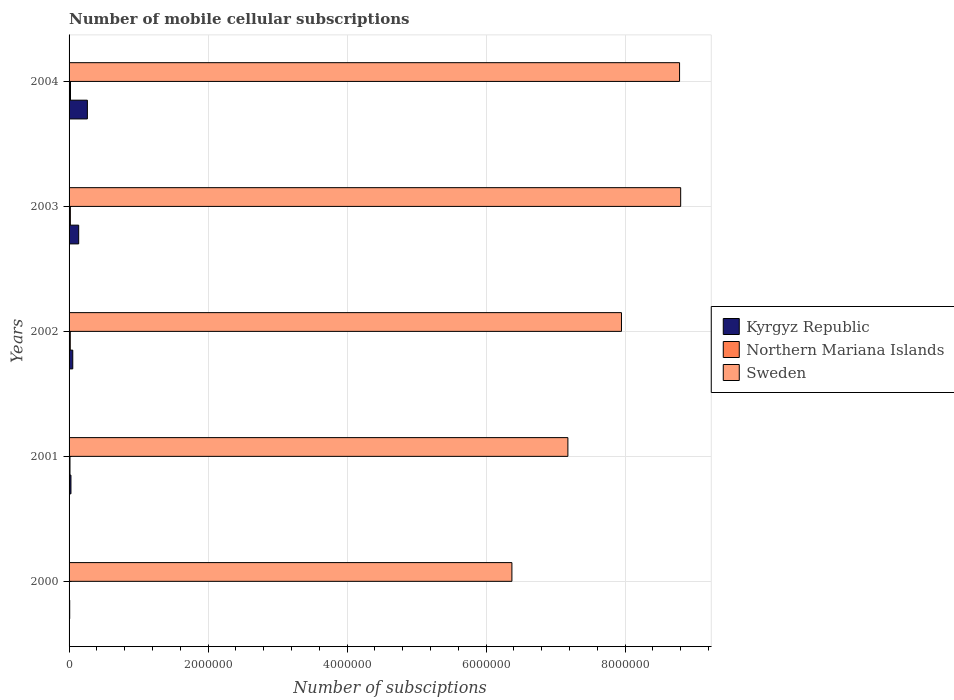How many groups of bars are there?
Your answer should be very brief. 5. Are the number of bars per tick equal to the number of legend labels?
Offer a very short reply. Yes. What is the label of the 4th group of bars from the top?
Your answer should be very brief. 2001. What is the number of mobile cellular subscriptions in Sweden in 2002?
Your answer should be very brief. 7.95e+06. Across all years, what is the maximum number of mobile cellular subscriptions in Sweden?
Make the answer very short. 8.80e+06. Across all years, what is the minimum number of mobile cellular subscriptions in Northern Mariana Islands?
Give a very brief answer. 3000. In which year was the number of mobile cellular subscriptions in Kyrgyz Republic maximum?
Provide a short and direct response. 2004. What is the total number of mobile cellular subscriptions in Kyrgyz Republic in the graph?
Ensure brevity in your answer.  4.91e+05. What is the difference between the number of mobile cellular subscriptions in Sweden in 2000 and that in 2001?
Provide a short and direct response. -8.06e+05. What is the difference between the number of mobile cellular subscriptions in Sweden in 2004 and the number of mobile cellular subscriptions in Northern Mariana Islands in 2002?
Provide a short and direct response. 8.77e+06. What is the average number of mobile cellular subscriptions in Sweden per year?
Make the answer very short. 7.82e+06. In the year 2002, what is the difference between the number of mobile cellular subscriptions in Northern Mariana Islands and number of mobile cellular subscriptions in Sweden?
Ensure brevity in your answer.  -7.93e+06. What is the ratio of the number of mobile cellular subscriptions in Kyrgyz Republic in 2002 to that in 2003?
Provide a succinct answer. 0.38. Is the number of mobile cellular subscriptions in Northern Mariana Islands in 2001 less than that in 2004?
Ensure brevity in your answer.  Yes. What is the difference between the highest and the second highest number of mobile cellular subscriptions in Sweden?
Your answer should be compact. 1.60e+04. What is the difference between the highest and the lowest number of mobile cellular subscriptions in Sweden?
Your answer should be very brief. 2.43e+06. In how many years, is the number of mobile cellular subscriptions in Sweden greater than the average number of mobile cellular subscriptions in Sweden taken over all years?
Your response must be concise. 3. What does the 1st bar from the top in 2001 represents?
Make the answer very short. Sweden. What does the 3rd bar from the bottom in 2003 represents?
Provide a short and direct response. Sweden. How many bars are there?
Ensure brevity in your answer.  15. Are all the bars in the graph horizontal?
Provide a short and direct response. Yes. How many years are there in the graph?
Give a very brief answer. 5. What is the difference between two consecutive major ticks on the X-axis?
Provide a short and direct response. 2.00e+06. Does the graph contain any zero values?
Provide a short and direct response. No. Does the graph contain grids?
Offer a very short reply. Yes. Where does the legend appear in the graph?
Keep it short and to the point. Center right. How are the legend labels stacked?
Your answer should be compact. Vertical. What is the title of the graph?
Your answer should be compact. Number of mobile cellular subscriptions. What is the label or title of the X-axis?
Keep it short and to the point. Number of subsciptions. What is the label or title of the Y-axis?
Ensure brevity in your answer.  Years. What is the Number of subsciptions of Kyrgyz Republic in 2000?
Ensure brevity in your answer.  9000. What is the Number of subsciptions in Northern Mariana Islands in 2000?
Keep it short and to the point. 3000. What is the Number of subsciptions of Sweden in 2000?
Offer a very short reply. 6.37e+06. What is the Number of subsciptions in Kyrgyz Republic in 2001?
Make the answer very short. 2.70e+04. What is the Number of subsciptions of Northern Mariana Islands in 2001?
Make the answer very short. 1.32e+04. What is the Number of subsciptions in Sweden in 2001?
Offer a very short reply. 7.18e+06. What is the Number of subsciptions of Kyrgyz Republic in 2002?
Offer a very short reply. 5.31e+04. What is the Number of subsciptions of Northern Mariana Islands in 2002?
Give a very brief answer. 1.71e+04. What is the Number of subsciptions of Sweden in 2002?
Your answer should be very brief. 7.95e+06. What is the Number of subsciptions of Kyrgyz Republic in 2003?
Your answer should be very brief. 1.38e+05. What is the Number of subsciptions in Northern Mariana Islands in 2003?
Ensure brevity in your answer.  1.86e+04. What is the Number of subsciptions of Sweden in 2003?
Your answer should be compact. 8.80e+06. What is the Number of subsciptions of Kyrgyz Republic in 2004?
Give a very brief answer. 2.63e+05. What is the Number of subsciptions in Northern Mariana Islands in 2004?
Keep it short and to the point. 2.05e+04. What is the Number of subsciptions in Sweden in 2004?
Ensure brevity in your answer.  8.78e+06. Across all years, what is the maximum Number of subsciptions in Kyrgyz Republic?
Provide a succinct answer. 2.63e+05. Across all years, what is the maximum Number of subsciptions of Northern Mariana Islands?
Your response must be concise. 2.05e+04. Across all years, what is the maximum Number of subsciptions of Sweden?
Provide a succinct answer. 8.80e+06. Across all years, what is the minimum Number of subsciptions of Kyrgyz Republic?
Offer a very short reply. 9000. Across all years, what is the minimum Number of subsciptions of Northern Mariana Islands?
Offer a very short reply. 3000. Across all years, what is the minimum Number of subsciptions in Sweden?
Your answer should be compact. 6.37e+06. What is the total Number of subsciptions in Kyrgyz Republic in the graph?
Provide a short and direct response. 4.91e+05. What is the total Number of subsciptions of Northern Mariana Islands in the graph?
Your answer should be very brief. 7.24e+04. What is the total Number of subsciptions of Sweden in the graph?
Your answer should be compact. 3.91e+07. What is the difference between the Number of subsciptions in Kyrgyz Republic in 2000 and that in 2001?
Your answer should be compact. -1.80e+04. What is the difference between the Number of subsciptions in Northern Mariana Islands in 2000 and that in 2001?
Provide a succinct answer. -1.02e+04. What is the difference between the Number of subsciptions of Sweden in 2000 and that in 2001?
Your response must be concise. -8.06e+05. What is the difference between the Number of subsciptions of Kyrgyz Republic in 2000 and that in 2002?
Offer a very short reply. -4.41e+04. What is the difference between the Number of subsciptions of Northern Mariana Islands in 2000 and that in 2002?
Offer a terse response. -1.41e+04. What is the difference between the Number of subsciptions in Sweden in 2000 and that in 2002?
Your response must be concise. -1.58e+06. What is the difference between the Number of subsciptions in Kyrgyz Republic in 2000 and that in 2003?
Make the answer very short. -1.29e+05. What is the difference between the Number of subsciptions of Northern Mariana Islands in 2000 and that in 2003?
Offer a terse response. -1.56e+04. What is the difference between the Number of subsciptions in Sweden in 2000 and that in 2003?
Your response must be concise. -2.43e+06. What is the difference between the Number of subsciptions of Kyrgyz Republic in 2000 and that in 2004?
Keep it short and to the point. -2.54e+05. What is the difference between the Number of subsciptions of Northern Mariana Islands in 2000 and that in 2004?
Keep it short and to the point. -1.75e+04. What is the difference between the Number of subsciptions of Sweden in 2000 and that in 2004?
Ensure brevity in your answer.  -2.41e+06. What is the difference between the Number of subsciptions in Kyrgyz Republic in 2001 and that in 2002?
Ensure brevity in your answer.  -2.61e+04. What is the difference between the Number of subsciptions in Northern Mariana Islands in 2001 and that in 2002?
Your response must be concise. -3937. What is the difference between the Number of subsciptions of Sweden in 2001 and that in 2002?
Keep it short and to the point. -7.71e+05. What is the difference between the Number of subsciptions in Kyrgyz Republic in 2001 and that in 2003?
Provide a short and direct response. -1.11e+05. What is the difference between the Number of subsciptions of Northern Mariana Islands in 2001 and that in 2003?
Offer a very short reply. -5419. What is the difference between the Number of subsciptions of Sweden in 2001 and that in 2003?
Give a very brief answer. -1.62e+06. What is the difference between the Number of subsciptions in Kyrgyz Republic in 2001 and that in 2004?
Give a very brief answer. -2.36e+05. What is the difference between the Number of subsciptions of Northern Mariana Islands in 2001 and that in 2004?
Your answer should be very brief. -7274. What is the difference between the Number of subsciptions of Sweden in 2001 and that in 2004?
Provide a short and direct response. -1.61e+06. What is the difference between the Number of subsciptions of Kyrgyz Republic in 2002 and that in 2003?
Give a very brief answer. -8.52e+04. What is the difference between the Number of subsciptions in Northern Mariana Islands in 2002 and that in 2003?
Your answer should be very brief. -1482. What is the difference between the Number of subsciptions of Sweden in 2002 and that in 2003?
Your response must be concise. -8.52e+05. What is the difference between the Number of subsciptions of Kyrgyz Republic in 2002 and that in 2004?
Offer a terse response. -2.10e+05. What is the difference between the Number of subsciptions in Northern Mariana Islands in 2002 and that in 2004?
Keep it short and to the point. -3337. What is the difference between the Number of subsciptions in Sweden in 2002 and that in 2004?
Provide a short and direct response. -8.36e+05. What is the difference between the Number of subsciptions in Kyrgyz Republic in 2003 and that in 2004?
Keep it short and to the point. -1.25e+05. What is the difference between the Number of subsciptions of Northern Mariana Islands in 2003 and that in 2004?
Your answer should be compact. -1855. What is the difference between the Number of subsciptions in Sweden in 2003 and that in 2004?
Your answer should be very brief. 1.60e+04. What is the difference between the Number of subsciptions of Kyrgyz Republic in 2000 and the Number of subsciptions of Northern Mariana Islands in 2001?
Keep it short and to the point. -4200. What is the difference between the Number of subsciptions of Kyrgyz Republic in 2000 and the Number of subsciptions of Sweden in 2001?
Ensure brevity in your answer.  -7.17e+06. What is the difference between the Number of subsciptions in Northern Mariana Islands in 2000 and the Number of subsciptions in Sweden in 2001?
Provide a succinct answer. -7.18e+06. What is the difference between the Number of subsciptions in Kyrgyz Republic in 2000 and the Number of subsciptions in Northern Mariana Islands in 2002?
Provide a succinct answer. -8137. What is the difference between the Number of subsciptions in Kyrgyz Republic in 2000 and the Number of subsciptions in Sweden in 2002?
Your answer should be compact. -7.94e+06. What is the difference between the Number of subsciptions in Northern Mariana Islands in 2000 and the Number of subsciptions in Sweden in 2002?
Provide a succinct answer. -7.95e+06. What is the difference between the Number of subsciptions in Kyrgyz Republic in 2000 and the Number of subsciptions in Northern Mariana Islands in 2003?
Provide a short and direct response. -9619. What is the difference between the Number of subsciptions in Kyrgyz Republic in 2000 and the Number of subsciptions in Sweden in 2003?
Provide a short and direct response. -8.79e+06. What is the difference between the Number of subsciptions in Northern Mariana Islands in 2000 and the Number of subsciptions in Sweden in 2003?
Give a very brief answer. -8.80e+06. What is the difference between the Number of subsciptions in Kyrgyz Republic in 2000 and the Number of subsciptions in Northern Mariana Islands in 2004?
Provide a short and direct response. -1.15e+04. What is the difference between the Number of subsciptions of Kyrgyz Republic in 2000 and the Number of subsciptions of Sweden in 2004?
Offer a very short reply. -8.78e+06. What is the difference between the Number of subsciptions in Northern Mariana Islands in 2000 and the Number of subsciptions in Sweden in 2004?
Give a very brief answer. -8.78e+06. What is the difference between the Number of subsciptions in Kyrgyz Republic in 2001 and the Number of subsciptions in Northern Mariana Islands in 2002?
Offer a terse response. 9863. What is the difference between the Number of subsciptions in Kyrgyz Republic in 2001 and the Number of subsciptions in Sweden in 2002?
Your answer should be compact. -7.92e+06. What is the difference between the Number of subsciptions in Northern Mariana Islands in 2001 and the Number of subsciptions in Sweden in 2002?
Ensure brevity in your answer.  -7.94e+06. What is the difference between the Number of subsciptions of Kyrgyz Republic in 2001 and the Number of subsciptions of Northern Mariana Islands in 2003?
Your response must be concise. 8381. What is the difference between the Number of subsciptions of Kyrgyz Republic in 2001 and the Number of subsciptions of Sweden in 2003?
Keep it short and to the point. -8.77e+06. What is the difference between the Number of subsciptions in Northern Mariana Islands in 2001 and the Number of subsciptions in Sweden in 2003?
Your answer should be compact. -8.79e+06. What is the difference between the Number of subsciptions of Kyrgyz Republic in 2001 and the Number of subsciptions of Northern Mariana Islands in 2004?
Provide a short and direct response. 6526. What is the difference between the Number of subsciptions of Kyrgyz Republic in 2001 and the Number of subsciptions of Sweden in 2004?
Offer a very short reply. -8.76e+06. What is the difference between the Number of subsciptions in Northern Mariana Islands in 2001 and the Number of subsciptions in Sweden in 2004?
Your answer should be very brief. -8.77e+06. What is the difference between the Number of subsciptions of Kyrgyz Republic in 2002 and the Number of subsciptions of Northern Mariana Islands in 2003?
Your answer should be very brief. 3.45e+04. What is the difference between the Number of subsciptions of Kyrgyz Republic in 2002 and the Number of subsciptions of Sweden in 2003?
Provide a short and direct response. -8.75e+06. What is the difference between the Number of subsciptions of Northern Mariana Islands in 2002 and the Number of subsciptions of Sweden in 2003?
Offer a terse response. -8.78e+06. What is the difference between the Number of subsciptions of Kyrgyz Republic in 2002 and the Number of subsciptions of Northern Mariana Islands in 2004?
Ensure brevity in your answer.  3.26e+04. What is the difference between the Number of subsciptions in Kyrgyz Republic in 2002 and the Number of subsciptions in Sweden in 2004?
Make the answer very short. -8.73e+06. What is the difference between the Number of subsciptions of Northern Mariana Islands in 2002 and the Number of subsciptions of Sweden in 2004?
Make the answer very short. -8.77e+06. What is the difference between the Number of subsciptions in Kyrgyz Republic in 2003 and the Number of subsciptions in Northern Mariana Islands in 2004?
Provide a succinct answer. 1.18e+05. What is the difference between the Number of subsciptions of Kyrgyz Republic in 2003 and the Number of subsciptions of Sweden in 2004?
Make the answer very short. -8.65e+06. What is the difference between the Number of subsciptions in Northern Mariana Islands in 2003 and the Number of subsciptions in Sweden in 2004?
Your response must be concise. -8.77e+06. What is the average Number of subsciptions of Kyrgyz Republic per year?
Your answer should be very brief. 9.81e+04. What is the average Number of subsciptions of Northern Mariana Islands per year?
Offer a very short reply. 1.45e+04. What is the average Number of subsciptions of Sweden per year?
Provide a succinct answer. 7.82e+06. In the year 2000, what is the difference between the Number of subsciptions in Kyrgyz Republic and Number of subsciptions in Northern Mariana Islands?
Give a very brief answer. 6000. In the year 2000, what is the difference between the Number of subsciptions in Kyrgyz Republic and Number of subsciptions in Sweden?
Your answer should be compact. -6.36e+06. In the year 2000, what is the difference between the Number of subsciptions of Northern Mariana Islands and Number of subsciptions of Sweden?
Your response must be concise. -6.37e+06. In the year 2001, what is the difference between the Number of subsciptions of Kyrgyz Republic and Number of subsciptions of Northern Mariana Islands?
Offer a terse response. 1.38e+04. In the year 2001, what is the difference between the Number of subsciptions of Kyrgyz Republic and Number of subsciptions of Sweden?
Your answer should be compact. -7.15e+06. In the year 2001, what is the difference between the Number of subsciptions of Northern Mariana Islands and Number of subsciptions of Sweden?
Ensure brevity in your answer.  -7.16e+06. In the year 2002, what is the difference between the Number of subsciptions of Kyrgyz Republic and Number of subsciptions of Northern Mariana Islands?
Offer a terse response. 3.59e+04. In the year 2002, what is the difference between the Number of subsciptions in Kyrgyz Republic and Number of subsciptions in Sweden?
Provide a succinct answer. -7.90e+06. In the year 2002, what is the difference between the Number of subsciptions of Northern Mariana Islands and Number of subsciptions of Sweden?
Give a very brief answer. -7.93e+06. In the year 2003, what is the difference between the Number of subsciptions in Kyrgyz Republic and Number of subsciptions in Northern Mariana Islands?
Keep it short and to the point. 1.20e+05. In the year 2003, what is the difference between the Number of subsciptions of Kyrgyz Republic and Number of subsciptions of Sweden?
Give a very brief answer. -8.66e+06. In the year 2003, what is the difference between the Number of subsciptions of Northern Mariana Islands and Number of subsciptions of Sweden?
Provide a short and direct response. -8.78e+06. In the year 2004, what is the difference between the Number of subsciptions in Kyrgyz Republic and Number of subsciptions in Northern Mariana Islands?
Offer a very short reply. 2.43e+05. In the year 2004, what is the difference between the Number of subsciptions of Kyrgyz Republic and Number of subsciptions of Sweden?
Keep it short and to the point. -8.52e+06. In the year 2004, what is the difference between the Number of subsciptions in Northern Mariana Islands and Number of subsciptions in Sweden?
Make the answer very short. -8.76e+06. What is the ratio of the Number of subsciptions of Northern Mariana Islands in 2000 to that in 2001?
Provide a succinct answer. 0.23. What is the ratio of the Number of subsciptions in Sweden in 2000 to that in 2001?
Make the answer very short. 0.89. What is the ratio of the Number of subsciptions in Kyrgyz Republic in 2000 to that in 2002?
Provide a succinct answer. 0.17. What is the ratio of the Number of subsciptions in Northern Mariana Islands in 2000 to that in 2002?
Offer a terse response. 0.18. What is the ratio of the Number of subsciptions in Sweden in 2000 to that in 2002?
Your answer should be very brief. 0.8. What is the ratio of the Number of subsciptions in Kyrgyz Republic in 2000 to that in 2003?
Give a very brief answer. 0.07. What is the ratio of the Number of subsciptions of Northern Mariana Islands in 2000 to that in 2003?
Keep it short and to the point. 0.16. What is the ratio of the Number of subsciptions of Sweden in 2000 to that in 2003?
Provide a short and direct response. 0.72. What is the ratio of the Number of subsciptions in Kyrgyz Republic in 2000 to that in 2004?
Offer a terse response. 0.03. What is the ratio of the Number of subsciptions of Northern Mariana Islands in 2000 to that in 2004?
Provide a short and direct response. 0.15. What is the ratio of the Number of subsciptions in Sweden in 2000 to that in 2004?
Your answer should be compact. 0.73. What is the ratio of the Number of subsciptions in Kyrgyz Republic in 2001 to that in 2002?
Keep it short and to the point. 0.51. What is the ratio of the Number of subsciptions in Northern Mariana Islands in 2001 to that in 2002?
Ensure brevity in your answer.  0.77. What is the ratio of the Number of subsciptions in Sweden in 2001 to that in 2002?
Provide a short and direct response. 0.9. What is the ratio of the Number of subsciptions of Kyrgyz Republic in 2001 to that in 2003?
Offer a terse response. 0.2. What is the ratio of the Number of subsciptions in Northern Mariana Islands in 2001 to that in 2003?
Give a very brief answer. 0.71. What is the ratio of the Number of subsciptions in Sweden in 2001 to that in 2003?
Offer a very short reply. 0.82. What is the ratio of the Number of subsciptions of Kyrgyz Republic in 2001 to that in 2004?
Your response must be concise. 0.1. What is the ratio of the Number of subsciptions in Northern Mariana Islands in 2001 to that in 2004?
Your response must be concise. 0.64. What is the ratio of the Number of subsciptions in Sweden in 2001 to that in 2004?
Provide a succinct answer. 0.82. What is the ratio of the Number of subsciptions of Kyrgyz Republic in 2002 to that in 2003?
Provide a short and direct response. 0.38. What is the ratio of the Number of subsciptions in Northern Mariana Islands in 2002 to that in 2003?
Give a very brief answer. 0.92. What is the ratio of the Number of subsciptions in Sweden in 2002 to that in 2003?
Offer a terse response. 0.9. What is the ratio of the Number of subsciptions of Kyrgyz Republic in 2002 to that in 2004?
Provide a short and direct response. 0.2. What is the ratio of the Number of subsciptions in Northern Mariana Islands in 2002 to that in 2004?
Ensure brevity in your answer.  0.84. What is the ratio of the Number of subsciptions in Sweden in 2002 to that in 2004?
Your answer should be very brief. 0.9. What is the ratio of the Number of subsciptions in Kyrgyz Republic in 2003 to that in 2004?
Your answer should be very brief. 0.53. What is the ratio of the Number of subsciptions of Northern Mariana Islands in 2003 to that in 2004?
Your response must be concise. 0.91. What is the ratio of the Number of subsciptions in Sweden in 2003 to that in 2004?
Provide a succinct answer. 1. What is the difference between the highest and the second highest Number of subsciptions of Kyrgyz Republic?
Give a very brief answer. 1.25e+05. What is the difference between the highest and the second highest Number of subsciptions of Northern Mariana Islands?
Ensure brevity in your answer.  1855. What is the difference between the highest and the second highest Number of subsciptions of Sweden?
Your response must be concise. 1.60e+04. What is the difference between the highest and the lowest Number of subsciptions in Kyrgyz Republic?
Provide a succinct answer. 2.54e+05. What is the difference between the highest and the lowest Number of subsciptions of Northern Mariana Islands?
Your answer should be compact. 1.75e+04. What is the difference between the highest and the lowest Number of subsciptions of Sweden?
Your answer should be very brief. 2.43e+06. 